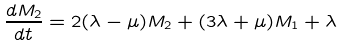Convert formula to latex. <formula><loc_0><loc_0><loc_500><loc_500>\frac { d M _ { 2 } } { d t } = 2 ( \lambda - \mu ) M _ { 2 } + ( 3 \lambda + \mu ) M _ { 1 } + \lambda</formula> 